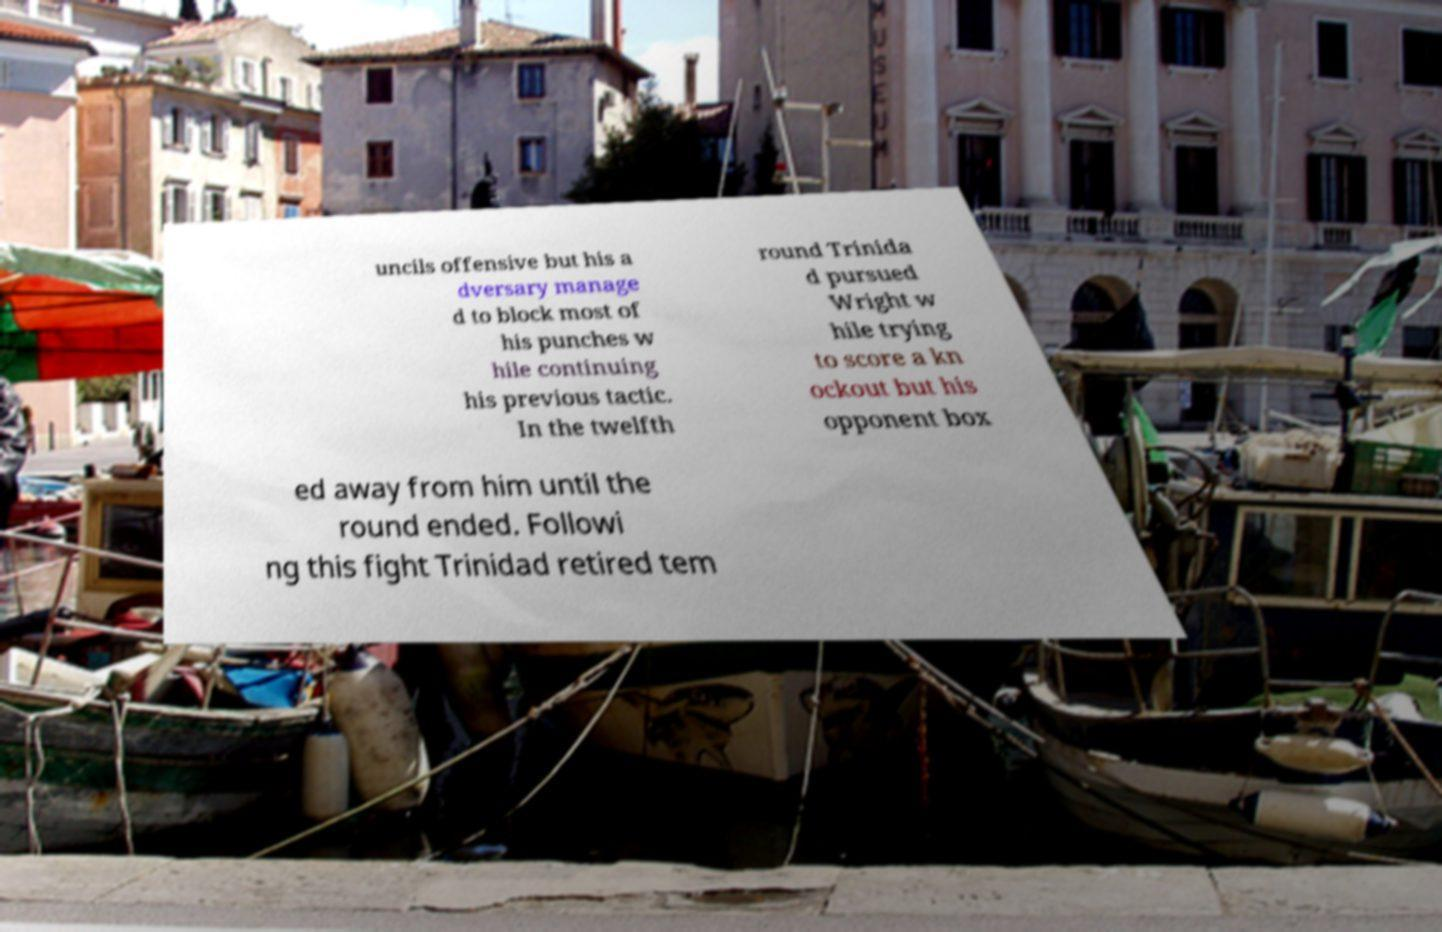Could you extract and type out the text from this image? uncils offensive but his a dversary manage d to block most of his punches w hile continuing his previous tactic. In the twelfth round Trinida d pursued Wright w hile trying to score a kn ockout but his opponent box ed away from him until the round ended. Followi ng this fight Trinidad retired tem 